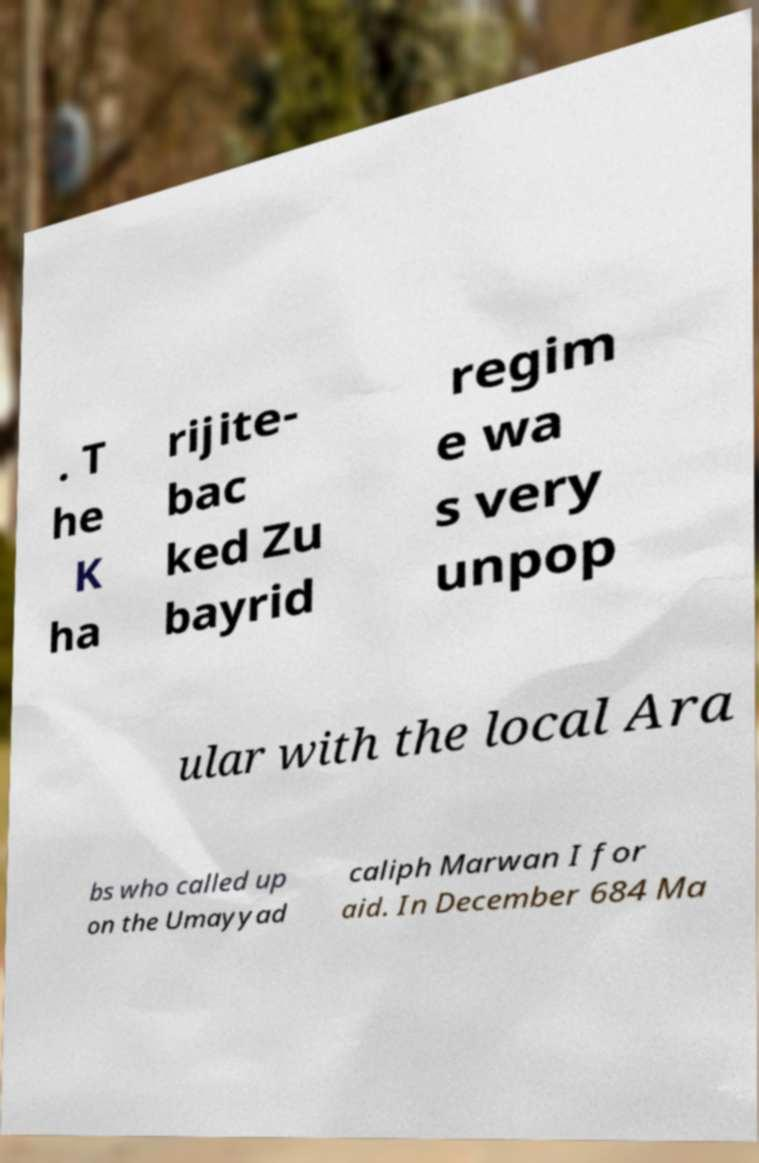Please read and relay the text visible in this image. What does it say? . T he K ha rijite- bac ked Zu bayrid regim e wa s very unpop ular with the local Ara bs who called up on the Umayyad caliph Marwan I for aid. In December 684 Ma 